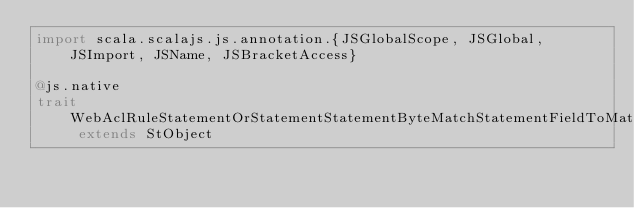Convert code to text. <code><loc_0><loc_0><loc_500><loc_500><_Scala_>import scala.scalajs.js.annotation.{JSGlobalScope, JSGlobal, JSImport, JSName, JSBracketAccess}

@js.native
trait WebAclRuleStatementOrStatementStatementByteMatchStatementFieldToMatchMethod extends StObject
</code> 